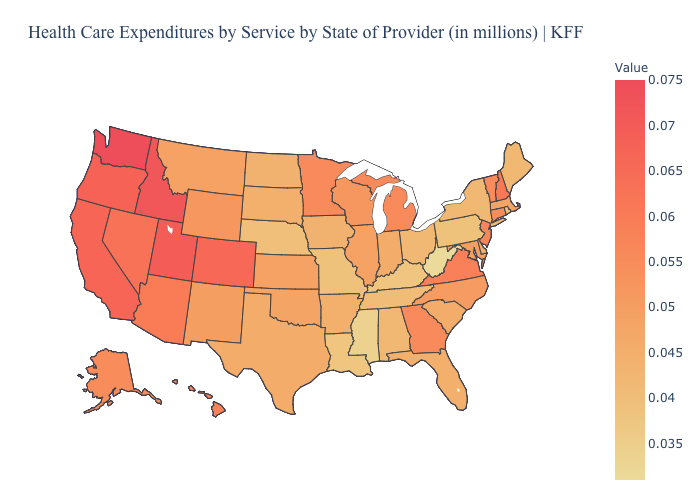Does Pennsylvania have the lowest value in the Northeast?
Keep it brief. Yes. Which states have the lowest value in the USA?
Answer briefly. West Virginia. Which states have the lowest value in the West?
Give a very brief answer. Montana. Does Montana have the lowest value in the West?
Answer briefly. Yes. Is the legend a continuous bar?
Answer briefly. Yes. 